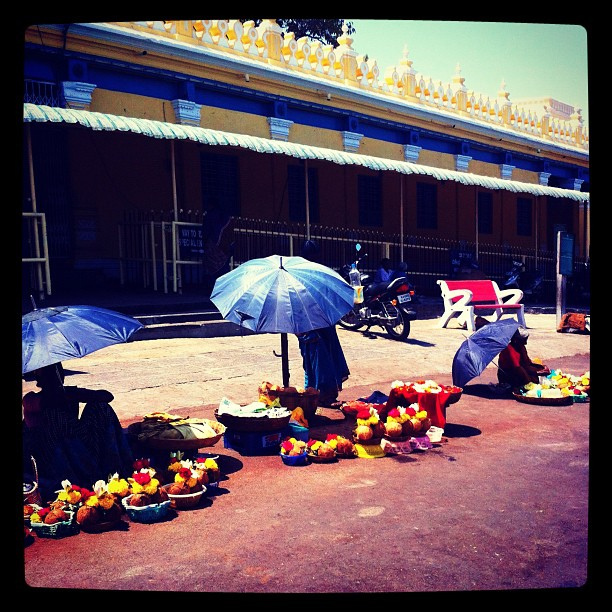<image>Are the people happy? I don't know if the people are happy. It is ambiguous as it can be both yes and no. What vacation destination is this? I am not sure about the exact vacation destination. It could be any place like Bali, Asia, Aruba, India, Thailand, Cuba, or Mexico. Are the people happy? I don't know if the people are happy. It can be seen both yes and no. What vacation destination is this? I don't know what vacation destination this is. It could be Bali, Aruba, India, Thailand, Cuba, or Mexico. 